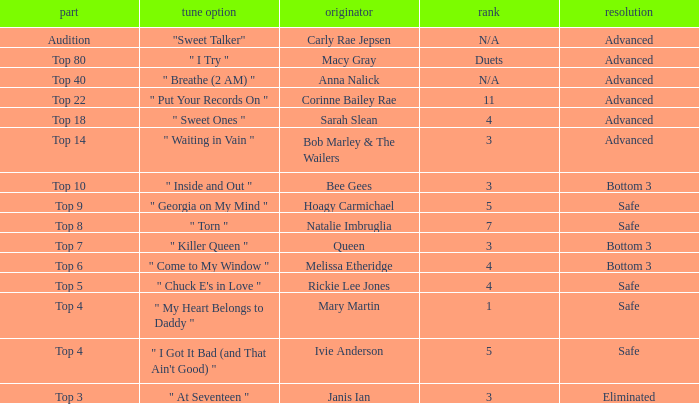What's the original artist of the song performed in the top 3 episode? Janis Ian. 